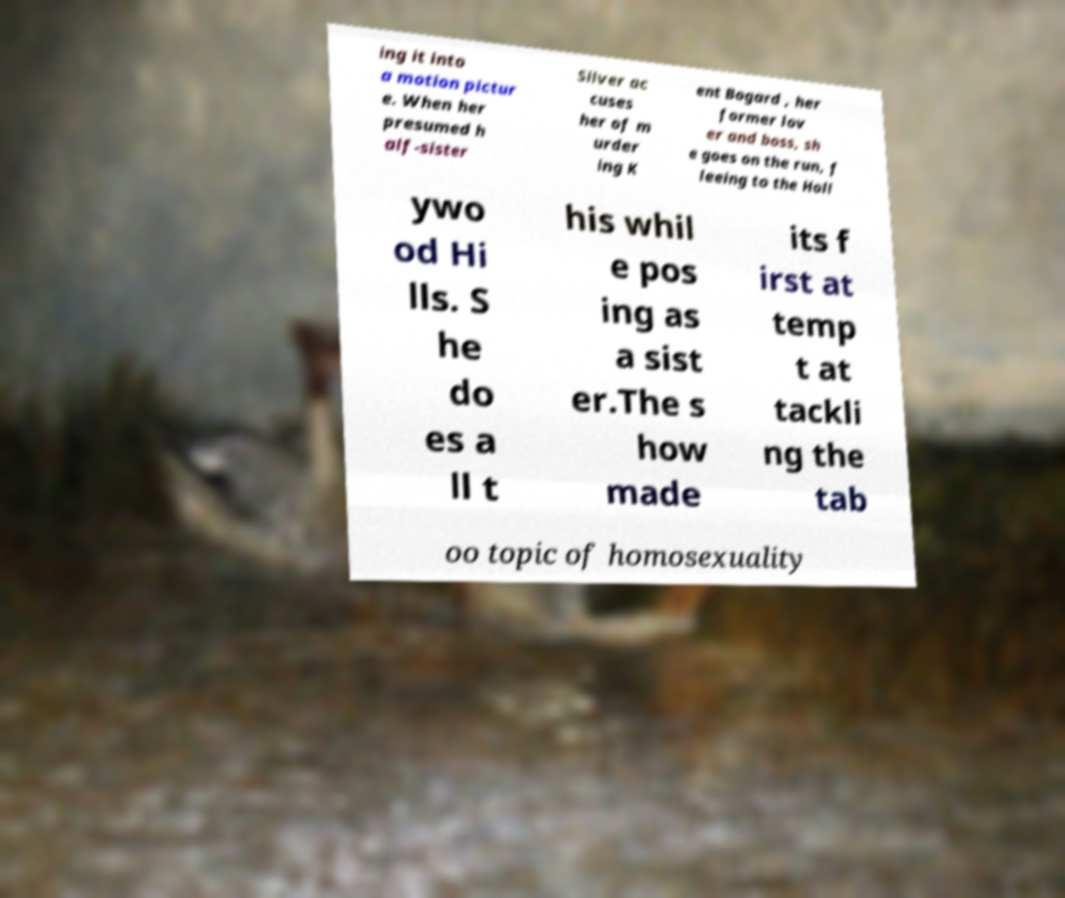Can you accurately transcribe the text from the provided image for me? ing it into a motion pictur e. When her presumed h alf-sister Silver ac cuses her of m urder ing K ent Bogard , her former lov er and boss, sh e goes on the run, f leeing to the Holl ywo od Hi lls. S he do es a ll t his whil e pos ing as a sist er.The s how made its f irst at temp t at tackli ng the tab oo topic of homosexuality 